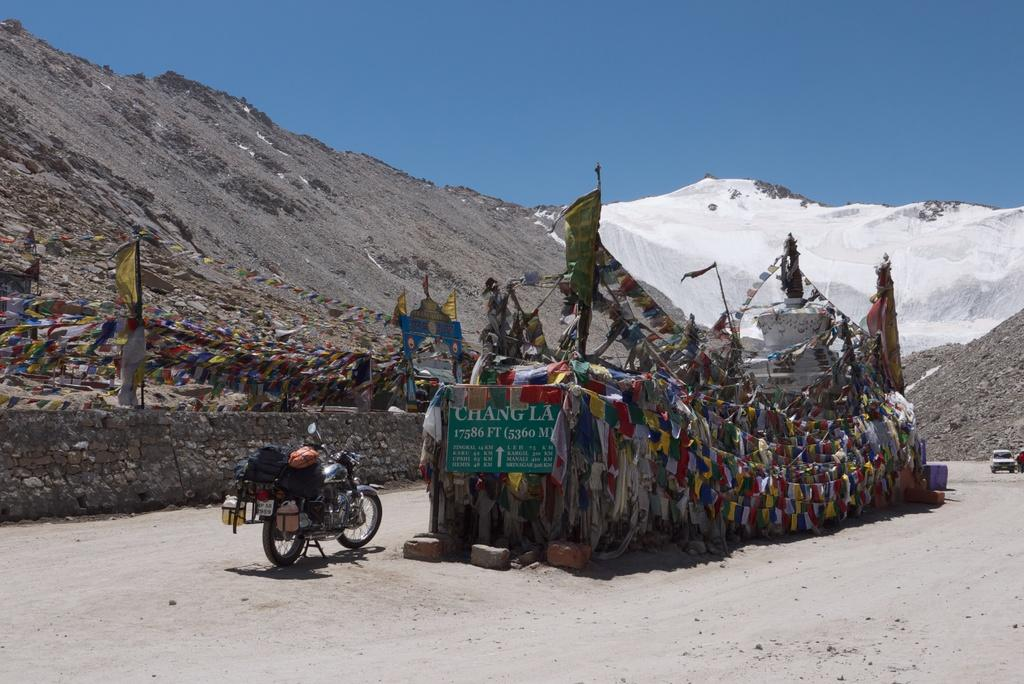What is the main object in the image? There is a bike in the image. How is the bike incorporated into the scene? The bike appears to be part of an architectural structure. What decorative elements are present around the bike? There are small flags around the bike in the foreground area. What can be seen in the distance in the image? Mountains and the sky are visible in the background of the image. What type of plot is the bike sitting on in the image? There is no plot visible in the image; the bike is part of an architectural structure. Can you tell me what kind of notebook the bike is holding in the image? There is no notebook present in the image; the bike is part of an architectural structure and is not holding any objects. 